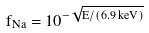<formula> <loc_0><loc_0><loc_500><loc_500>f _ { N a } = 1 0 ^ { - \sqrt { E / ( 6 . 9 \, k e V ) } }</formula> 